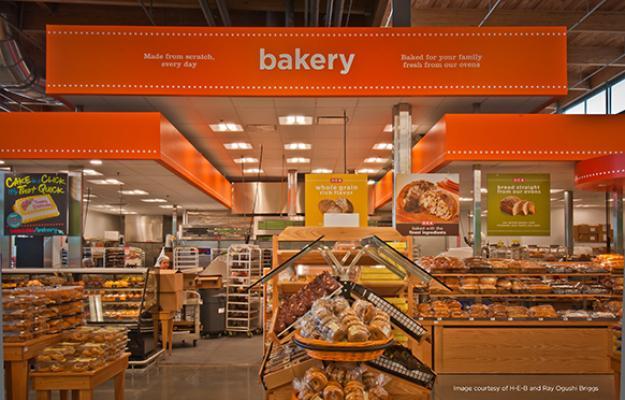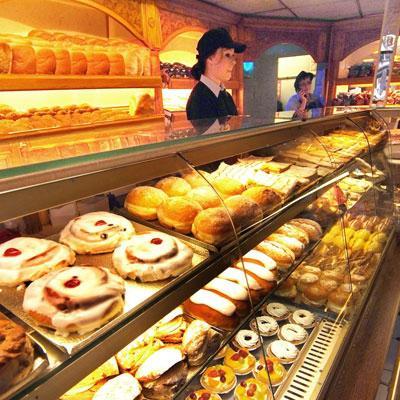The first image is the image on the left, the second image is the image on the right. Analyze the images presented: Is the assertion "The right image shows at least one person in a hat standing behind a straight glass-fronted cabinet filled with baked treats." valid? Answer yes or no. Yes. 